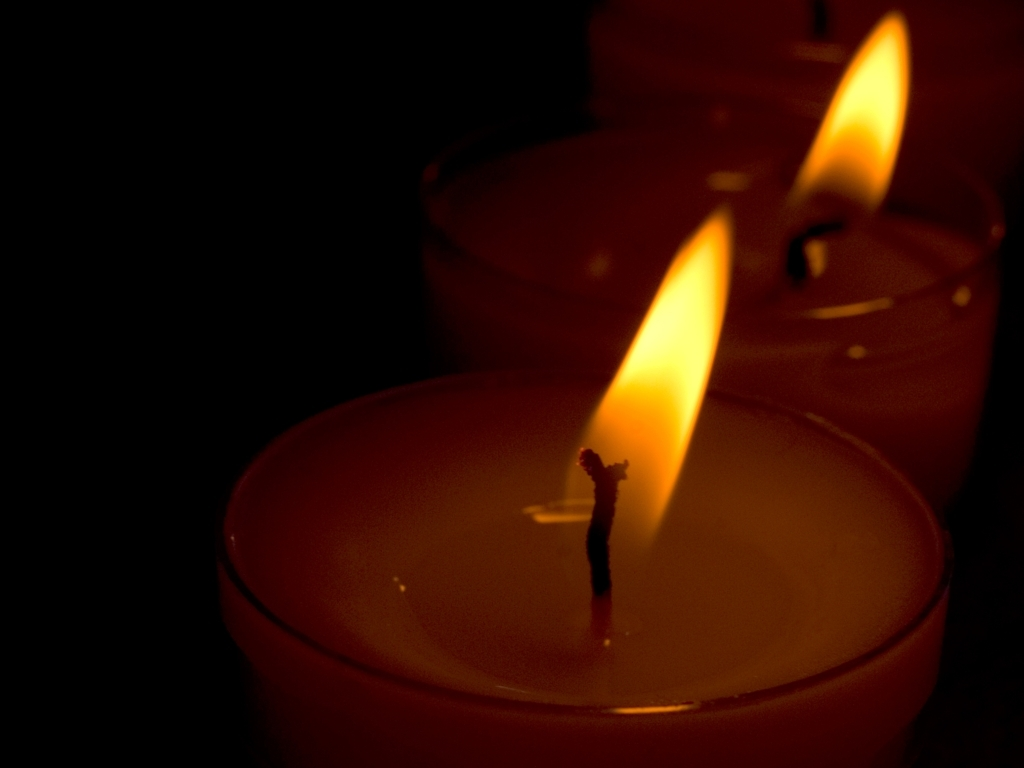What emotion does this image evoke, and why might it be used in certain contexts? The warm glow and the soft lighting of the candles in the image evoke a sense of calm and tranquility. Such an image might be used in contexts that aim to promote relaxation and peace, such as spa advertisement, reflective blog posts, or materials for meditation and mindfulness practices. 